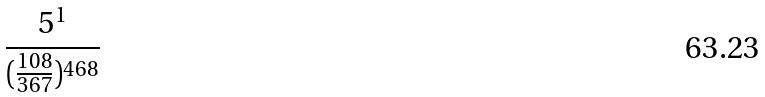<formula> <loc_0><loc_0><loc_500><loc_500>\frac { 5 ^ { 1 } } { ( \frac { 1 0 8 } { 3 6 7 } ) ^ { 4 6 8 } }</formula> 